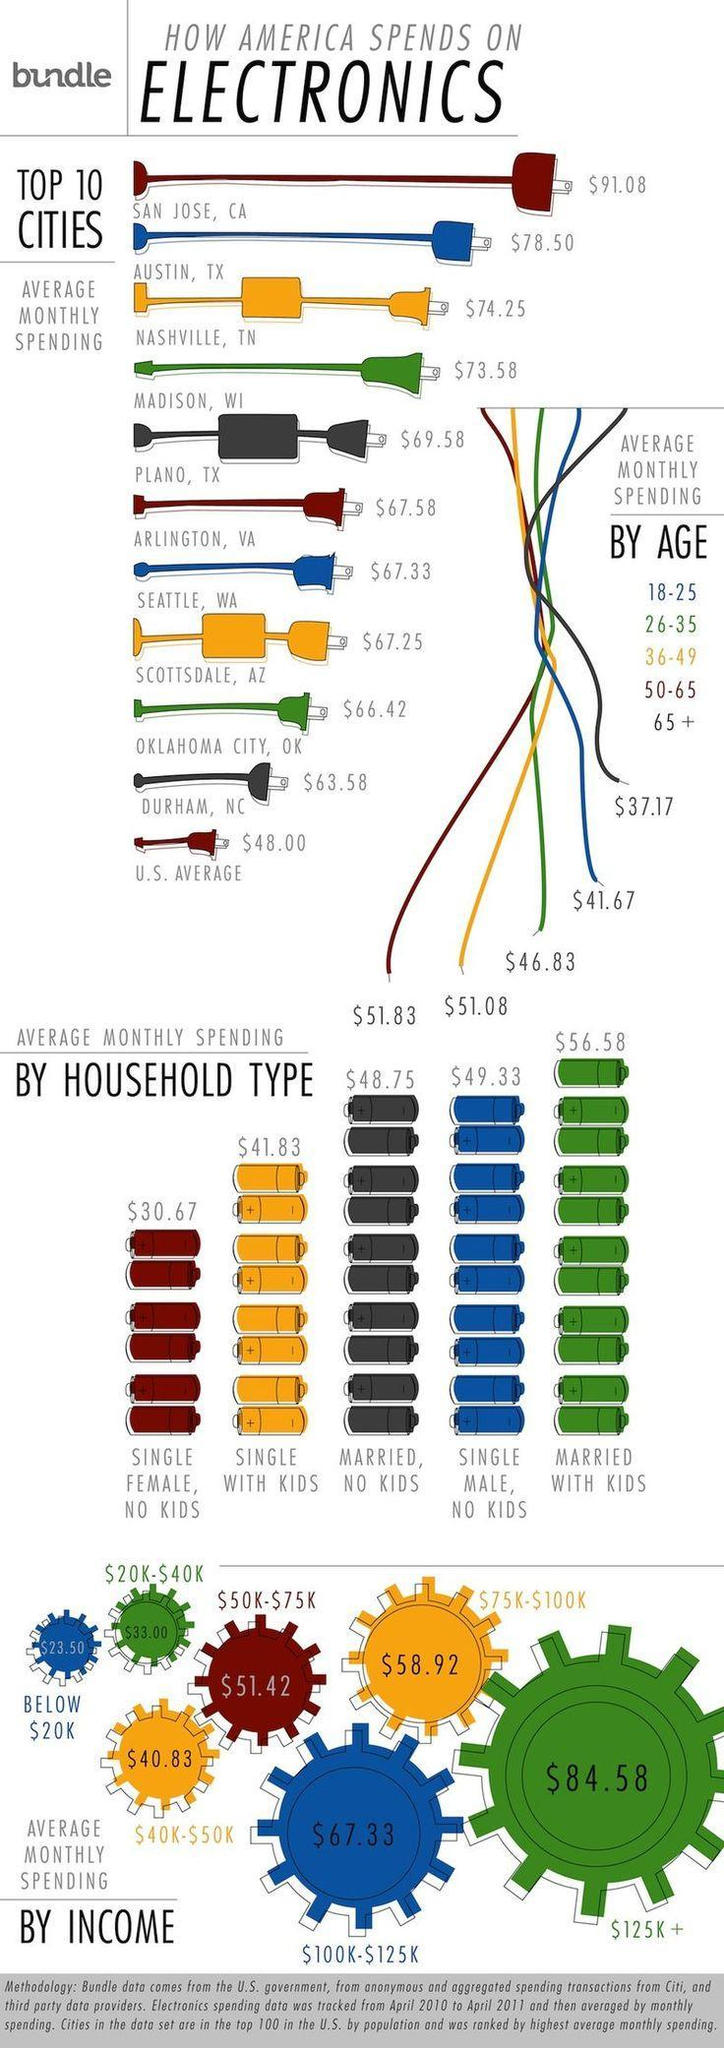How much does single women save than single males by cutting down expenses on electronics?
Answer the question with a short phrase. $18.33 Which income group spends the most on electronics, $40K-50K, $100-$125k, or $125K+? $125K+ What is difference in average monthly spending of a household with married couples with and without kids? $7.83 What is average amount spent on electronics by the income group earning $ 30K? $33.00 What is total monthly spending(avg) in Austin and Plano? $146.08 What is the average monthly spending of the age group 50-65 on electronics? $51.83 